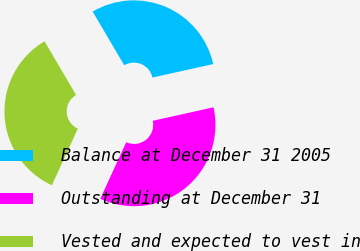Convert chart to OTSL. <chart><loc_0><loc_0><loc_500><loc_500><pie_chart><fcel>Balance at December 31 2005<fcel>Outstanding at December 31<fcel>Vested and expected to vest in<nl><fcel>29.99%<fcel>35.31%<fcel>34.7%<nl></chart> 